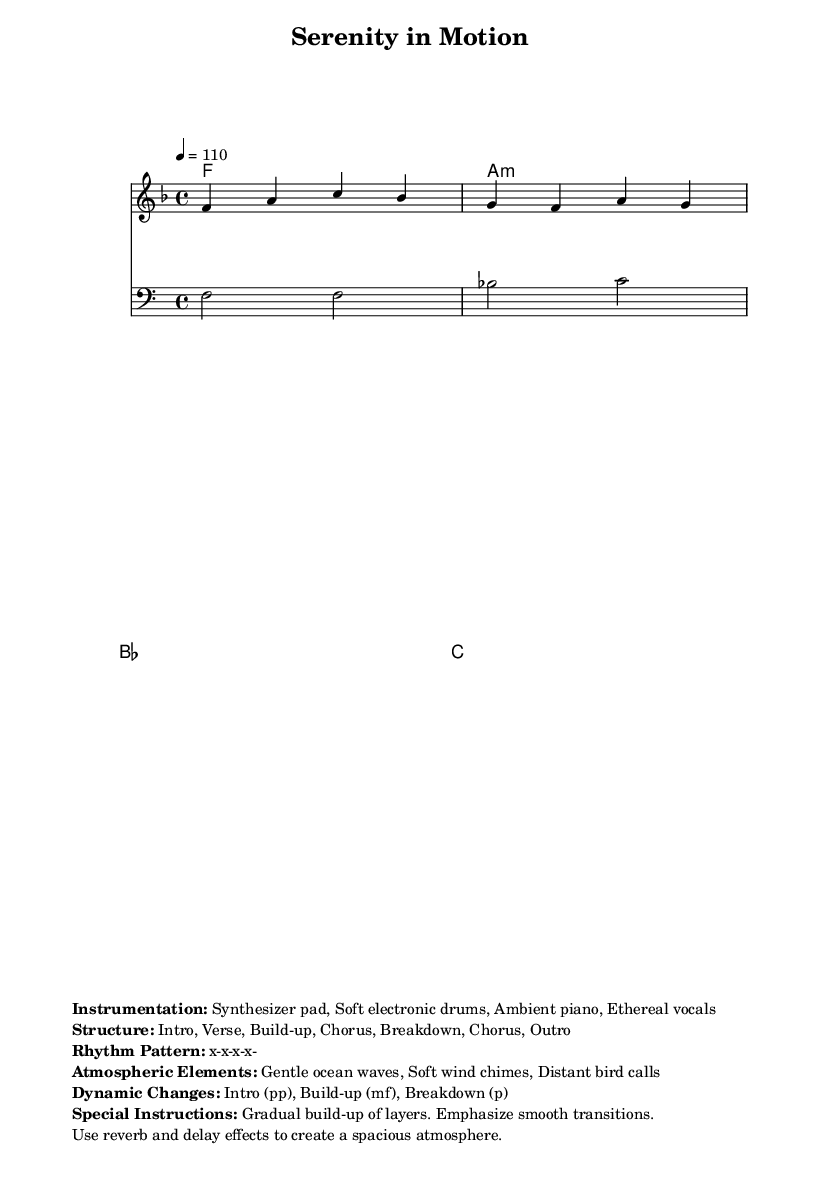What is the key signature of this music? The key signature is F major, which contains one flat (B-flat).
Answer: F major What is the time signature of this music? The time signature is 4/4, which indicates four beats per measure with a quarter note receiving one beat.
Answer: 4/4 What is the tempo marking of this piece? The tempo is marked at quarter note = 110, indicating a moderate speed.
Answer: 110 How many sections are in the structure of this composition? The structure includes six sections: Intro, Verse, Build-up, Chorus, Breakdown, Chorus, Outro, totaling six distinct parts.
Answer: Six What dynamic changes occur in the music? The dynamics change from pianississimo (pp) during the intro to mezzo-forte (mf) during the build-up, and to piano (p) in the breakdown, reflecting an emotional arc.
Answer: pp, mf, p What instruments are used in this composition? The instrumentation includes synthesizer pad, soft electronic drums, ambient piano, and ethereal vocals, creating a soothing soundscape typical of ambient dance music.
Answer: Synthesizer pad, Soft electronic drums, Ambient piano, Ethereal vocals 